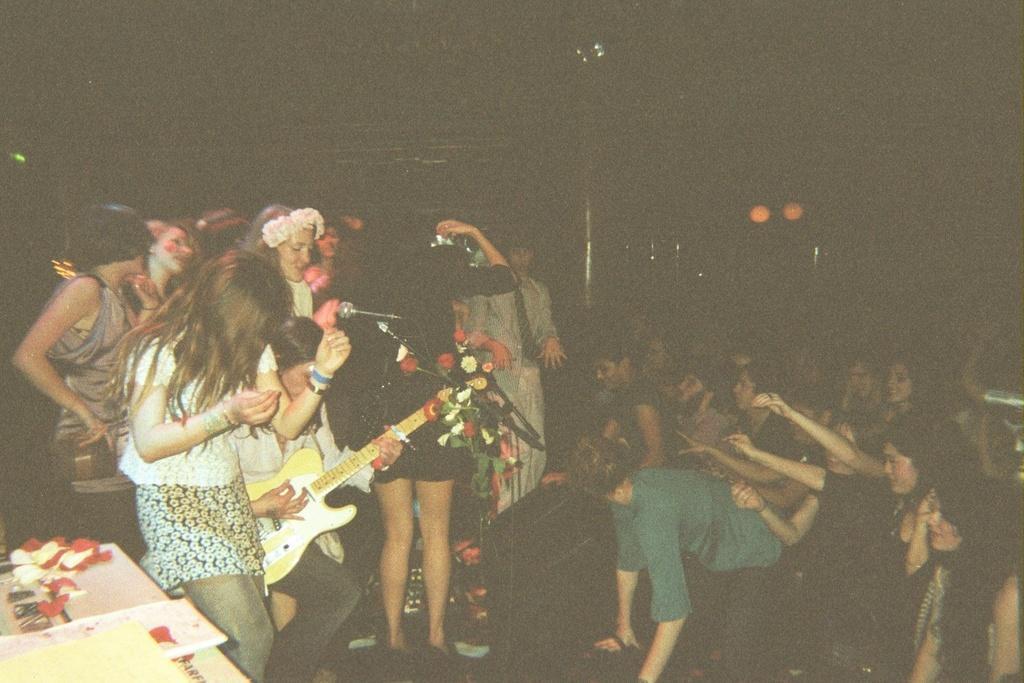Describe this image in one or two sentences. In this image we can see some group of people standing on the stage and performing something, there are some group of people in front of the stage where they are cheering for the people on the stage, hear this woman is playing a guitar, on the left bottom of the image we can see a table. 